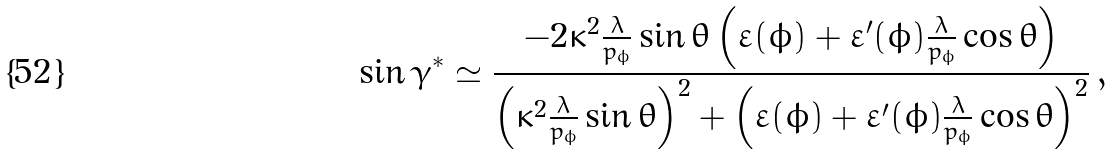Convert formula to latex. <formula><loc_0><loc_0><loc_500><loc_500>\sin { \gamma ^ { * } } \simeq \frac { - 2 \kappa ^ { 2 } \frac { \lambda } { p _ { \phi } } \sin { \theta } \left ( \varepsilon ( \phi ) + \varepsilon ^ { \prime } ( \phi ) \frac { \lambda } { p _ { \phi } } \cos { \theta } \right ) } { \left ( \kappa ^ { 2 } \frac { \lambda } { p _ { \phi } } \sin { \theta } \right ) ^ { 2 } + \left ( \varepsilon ( \phi ) + \varepsilon ^ { \prime } ( \phi ) \frac { \lambda } { p _ { \phi } } \cos { \theta } \right ) ^ { 2 } } \, ,</formula> 